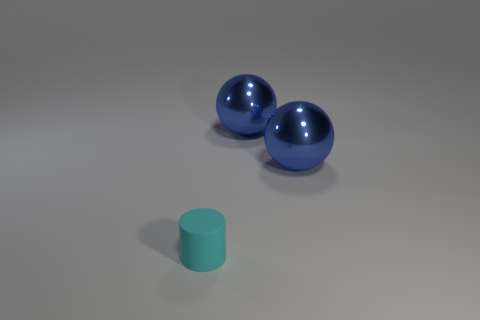Add 3 small cyan cylinders. How many objects exist? 6 Subtract all cylinders. How many objects are left? 2 Add 1 blue spheres. How many blue spheres exist? 3 Subtract 0 purple cylinders. How many objects are left? 3 Subtract all gray matte cylinders. Subtract all blue shiny spheres. How many objects are left? 1 Add 1 metal objects. How many metal objects are left? 3 